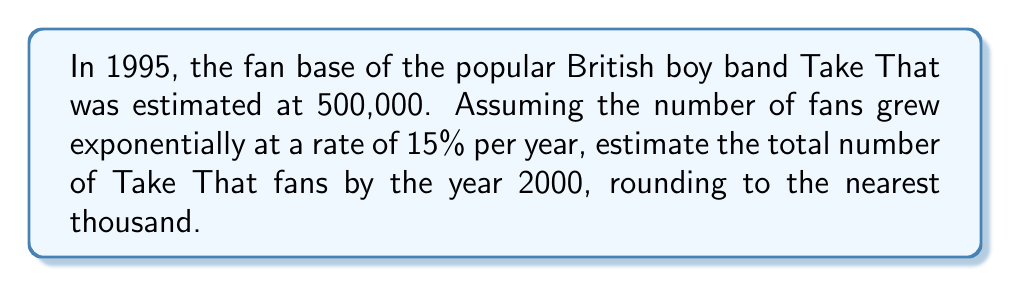Solve this math problem. Let's approach this step-by-step:

1) The initial number of fans in 1995 is 500,000.
2) The growth rate is 15% per year, which means the multiplier is 1.15.
3) The time period is 5 years (from 1995 to 2000).

We can use the exponential growth formula:

$$A = P(1 + r)^t$$

Where:
$A$ = Final amount
$P$ = Initial principal balance
$r$ = Annual growth rate (in decimal form)
$t$ = Number of years

Plugging in our values:

$$A = 500,000(1 + 0.15)^5$$

$$A = 500,000(1.15)^5$$

Now, let's calculate:

$$A = 500,000 * 2.0113689$$

$$A = 1,005,684.45$$

Rounding to the nearest thousand:

$$A ≈ 1,006,000$$
Answer: 1,006,000 fans 